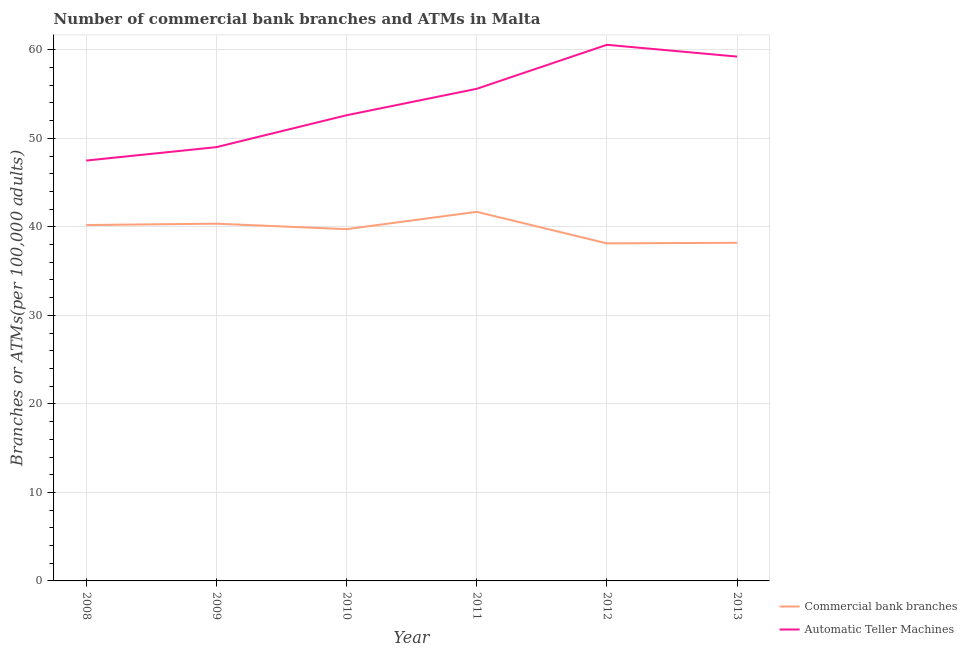Does the line corresponding to number of commercal bank branches intersect with the line corresponding to number of atms?
Your answer should be compact. No. Is the number of lines equal to the number of legend labels?
Offer a terse response. Yes. What is the number of commercal bank branches in 2012?
Your answer should be very brief. 38.14. Across all years, what is the maximum number of atms?
Make the answer very short. 60.57. Across all years, what is the minimum number of atms?
Provide a succinct answer. 47.49. In which year was the number of atms maximum?
Offer a terse response. 2012. What is the total number of atms in the graph?
Provide a short and direct response. 324.51. What is the difference between the number of atms in 2008 and that in 2013?
Give a very brief answer. -11.75. What is the difference between the number of commercal bank branches in 2012 and the number of atms in 2010?
Provide a short and direct response. -14.47. What is the average number of atms per year?
Offer a very short reply. 54.09. In the year 2011, what is the difference between the number of atms and number of commercal bank branches?
Provide a short and direct response. 13.9. In how many years, is the number of commercal bank branches greater than 56?
Your answer should be very brief. 0. What is the ratio of the number of atms in 2008 to that in 2011?
Your answer should be very brief. 0.85. What is the difference between the highest and the second highest number of atms?
Offer a very short reply. 1.33. What is the difference between the highest and the lowest number of atms?
Keep it short and to the point. 13.08. In how many years, is the number of atms greater than the average number of atms taken over all years?
Provide a succinct answer. 3. Does the number of commercal bank branches monotonically increase over the years?
Provide a short and direct response. No. Is the number of commercal bank branches strictly less than the number of atms over the years?
Your response must be concise. Yes. How many lines are there?
Your answer should be very brief. 2. How many years are there in the graph?
Make the answer very short. 6. What is the difference between two consecutive major ticks on the Y-axis?
Ensure brevity in your answer.  10. Are the values on the major ticks of Y-axis written in scientific E-notation?
Provide a short and direct response. No. How are the legend labels stacked?
Make the answer very short. Vertical. What is the title of the graph?
Ensure brevity in your answer.  Number of commercial bank branches and ATMs in Malta. Does "Under-5(female)" appear as one of the legend labels in the graph?
Give a very brief answer. No. What is the label or title of the Y-axis?
Provide a succinct answer. Branches or ATMs(per 100,0 adults). What is the Branches or ATMs(per 100,000 adults) in Commercial bank branches in 2008?
Provide a succinct answer. 40.21. What is the Branches or ATMs(per 100,000 adults) in Automatic Teller Machines in 2008?
Provide a succinct answer. 47.49. What is the Branches or ATMs(per 100,000 adults) of Commercial bank branches in 2009?
Make the answer very short. 40.36. What is the Branches or ATMs(per 100,000 adults) of Automatic Teller Machines in 2009?
Keep it short and to the point. 49.01. What is the Branches or ATMs(per 100,000 adults) in Commercial bank branches in 2010?
Provide a short and direct response. 39.74. What is the Branches or ATMs(per 100,000 adults) in Automatic Teller Machines in 2010?
Provide a short and direct response. 52.61. What is the Branches or ATMs(per 100,000 adults) of Commercial bank branches in 2011?
Offer a very short reply. 41.7. What is the Branches or ATMs(per 100,000 adults) in Automatic Teller Machines in 2011?
Your response must be concise. 55.6. What is the Branches or ATMs(per 100,000 adults) in Commercial bank branches in 2012?
Offer a terse response. 38.14. What is the Branches or ATMs(per 100,000 adults) in Automatic Teller Machines in 2012?
Your answer should be very brief. 60.57. What is the Branches or ATMs(per 100,000 adults) in Commercial bank branches in 2013?
Provide a succinct answer. 38.2. What is the Branches or ATMs(per 100,000 adults) in Automatic Teller Machines in 2013?
Offer a terse response. 59.24. Across all years, what is the maximum Branches or ATMs(per 100,000 adults) in Commercial bank branches?
Your response must be concise. 41.7. Across all years, what is the maximum Branches or ATMs(per 100,000 adults) of Automatic Teller Machines?
Ensure brevity in your answer.  60.57. Across all years, what is the minimum Branches or ATMs(per 100,000 adults) in Commercial bank branches?
Give a very brief answer. 38.14. Across all years, what is the minimum Branches or ATMs(per 100,000 adults) in Automatic Teller Machines?
Offer a very short reply. 47.49. What is the total Branches or ATMs(per 100,000 adults) in Commercial bank branches in the graph?
Ensure brevity in your answer.  238.34. What is the total Branches or ATMs(per 100,000 adults) of Automatic Teller Machines in the graph?
Provide a succinct answer. 324.51. What is the difference between the Branches or ATMs(per 100,000 adults) of Commercial bank branches in 2008 and that in 2009?
Provide a short and direct response. -0.15. What is the difference between the Branches or ATMs(per 100,000 adults) of Automatic Teller Machines in 2008 and that in 2009?
Your answer should be very brief. -1.52. What is the difference between the Branches or ATMs(per 100,000 adults) of Commercial bank branches in 2008 and that in 2010?
Provide a succinct answer. 0.46. What is the difference between the Branches or ATMs(per 100,000 adults) in Automatic Teller Machines in 2008 and that in 2010?
Ensure brevity in your answer.  -5.12. What is the difference between the Branches or ATMs(per 100,000 adults) in Commercial bank branches in 2008 and that in 2011?
Your response must be concise. -1.49. What is the difference between the Branches or ATMs(per 100,000 adults) of Automatic Teller Machines in 2008 and that in 2011?
Make the answer very short. -8.11. What is the difference between the Branches or ATMs(per 100,000 adults) of Commercial bank branches in 2008 and that in 2012?
Offer a very short reply. 2.07. What is the difference between the Branches or ATMs(per 100,000 adults) of Automatic Teller Machines in 2008 and that in 2012?
Offer a terse response. -13.08. What is the difference between the Branches or ATMs(per 100,000 adults) in Commercial bank branches in 2008 and that in 2013?
Your answer should be compact. 2.01. What is the difference between the Branches or ATMs(per 100,000 adults) in Automatic Teller Machines in 2008 and that in 2013?
Offer a terse response. -11.75. What is the difference between the Branches or ATMs(per 100,000 adults) of Commercial bank branches in 2009 and that in 2010?
Your answer should be compact. 0.62. What is the difference between the Branches or ATMs(per 100,000 adults) of Automatic Teller Machines in 2009 and that in 2010?
Ensure brevity in your answer.  -3.6. What is the difference between the Branches or ATMs(per 100,000 adults) of Commercial bank branches in 2009 and that in 2011?
Offer a terse response. -1.34. What is the difference between the Branches or ATMs(per 100,000 adults) in Automatic Teller Machines in 2009 and that in 2011?
Offer a very short reply. -6.59. What is the difference between the Branches or ATMs(per 100,000 adults) of Commercial bank branches in 2009 and that in 2012?
Give a very brief answer. 2.22. What is the difference between the Branches or ATMs(per 100,000 adults) of Automatic Teller Machines in 2009 and that in 2012?
Your answer should be compact. -11.56. What is the difference between the Branches or ATMs(per 100,000 adults) in Commercial bank branches in 2009 and that in 2013?
Your answer should be very brief. 2.16. What is the difference between the Branches or ATMs(per 100,000 adults) of Automatic Teller Machines in 2009 and that in 2013?
Offer a terse response. -10.23. What is the difference between the Branches or ATMs(per 100,000 adults) in Commercial bank branches in 2010 and that in 2011?
Keep it short and to the point. -1.96. What is the difference between the Branches or ATMs(per 100,000 adults) of Automatic Teller Machines in 2010 and that in 2011?
Ensure brevity in your answer.  -2.99. What is the difference between the Branches or ATMs(per 100,000 adults) in Commercial bank branches in 2010 and that in 2012?
Offer a terse response. 1.61. What is the difference between the Branches or ATMs(per 100,000 adults) in Automatic Teller Machines in 2010 and that in 2012?
Provide a short and direct response. -7.96. What is the difference between the Branches or ATMs(per 100,000 adults) of Commercial bank branches in 2010 and that in 2013?
Give a very brief answer. 1.54. What is the difference between the Branches or ATMs(per 100,000 adults) of Automatic Teller Machines in 2010 and that in 2013?
Ensure brevity in your answer.  -6.63. What is the difference between the Branches or ATMs(per 100,000 adults) of Commercial bank branches in 2011 and that in 2012?
Your answer should be compact. 3.56. What is the difference between the Branches or ATMs(per 100,000 adults) in Automatic Teller Machines in 2011 and that in 2012?
Keep it short and to the point. -4.97. What is the difference between the Branches or ATMs(per 100,000 adults) in Commercial bank branches in 2011 and that in 2013?
Ensure brevity in your answer.  3.5. What is the difference between the Branches or ATMs(per 100,000 adults) in Automatic Teller Machines in 2011 and that in 2013?
Provide a succinct answer. -3.64. What is the difference between the Branches or ATMs(per 100,000 adults) in Commercial bank branches in 2012 and that in 2013?
Keep it short and to the point. -0.06. What is the difference between the Branches or ATMs(per 100,000 adults) of Automatic Teller Machines in 2012 and that in 2013?
Provide a succinct answer. 1.33. What is the difference between the Branches or ATMs(per 100,000 adults) of Commercial bank branches in 2008 and the Branches or ATMs(per 100,000 adults) of Automatic Teller Machines in 2009?
Provide a short and direct response. -8.8. What is the difference between the Branches or ATMs(per 100,000 adults) in Commercial bank branches in 2008 and the Branches or ATMs(per 100,000 adults) in Automatic Teller Machines in 2010?
Offer a terse response. -12.4. What is the difference between the Branches or ATMs(per 100,000 adults) in Commercial bank branches in 2008 and the Branches or ATMs(per 100,000 adults) in Automatic Teller Machines in 2011?
Your response must be concise. -15.39. What is the difference between the Branches or ATMs(per 100,000 adults) of Commercial bank branches in 2008 and the Branches or ATMs(per 100,000 adults) of Automatic Teller Machines in 2012?
Offer a very short reply. -20.36. What is the difference between the Branches or ATMs(per 100,000 adults) in Commercial bank branches in 2008 and the Branches or ATMs(per 100,000 adults) in Automatic Teller Machines in 2013?
Your response must be concise. -19.03. What is the difference between the Branches or ATMs(per 100,000 adults) of Commercial bank branches in 2009 and the Branches or ATMs(per 100,000 adults) of Automatic Teller Machines in 2010?
Your answer should be very brief. -12.25. What is the difference between the Branches or ATMs(per 100,000 adults) in Commercial bank branches in 2009 and the Branches or ATMs(per 100,000 adults) in Automatic Teller Machines in 2011?
Your response must be concise. -15.24. What is the difference between the Branches or ATMs(per 100,000 adults) of Commercial bank branches in 2009 and the Branches or ATMs(per 100,000 adults) of Automatic Teller Machines in 2012?
Offer a terse response. -20.21. What is the difference between the Branches or ATMs(per 100,000 adults) of Commercial bank branches in 2009 and the Branches or ATMs(per 100,000 adults) of Automatic Teller Machines in 2013?
Offer a terse response. -18.88. What is the difference between the Branches or ATMs(per 100,000 adults) of Commercial bank branches in 2010 and the Branches or ATMs(per 100,000 adults) of Automatic Teller Machines in 2011?
Offer a terse response. -15.85. What is the difference between the Branches or ATMs(per 100,000 adults) of Commercial bank branches in 2010 and the Branches or ATMs(per 100,000 adults) of Automatic Teller Machines in 2012?
Offer a terse response. -20.83. What is the difference between the Branches or ATMs(per 100,000 adults) of Commercial bank branches in 2010 and the Branches or ATMs(per 100,000 adults) of Automatic Teller Machines in 2013?
Offer a very short reply. -19.49. What is the difference between the Branches or ATMs(per 100,000 adults) in Commercial bank branches in 2011 and the Branches or ATMs(per 100,000 adults) in Automatic Teller Machines in 2012?
Make the answer very short. -18.87. What is the difference between the Branches or ATMs(per 100,000 adults) of Commercial bank branches in 2011 and the Branches or ATMs(per 100,000 adults) of Automatic Teller Machines in 2013?
Keep it short and to the point. -17.54. What is the difference between the Branches or ATMs(per 100,000 adults) in Commercial bank branches in 2012 and the Branches or ATMs(per 100,000 adults) in Automatic Teller Machines in 2013?
Make the answer very short. -21.1. What is the average Branches or ATMs(per 100,000 adults) of Commercial bank branches per year?
Give a very brief answer. 39.72. What is the average Branches or ATMs(per 100,000 adults) of Automatic Teller Machines per year?
Provide a succinct answer. 54.09. In the year 2008, what is the difference between the Branches or ATMs(per 100,000 adults) of Commercial bank branches and Branches or ATMs(per 100,000 adults) of Automatic Teller Machines?
Offer a terse response. -7.28. In the year 2009, what is the difference between the Branches or ATMs(per 100,000 adults) of Commercial bank branches and Branches or ATMs(per 100,000 adults) of Automatic Teller Machines?
Your answer should be compact. -8.65. In the year 2010, what is the difference between the Branches or ATMs(per 100,000 adults) in Commercial bank branches and Branches or ATMs(per 100,000 adults) in Automatic Teller Machines?
Keep it short and to the point. -12.87. In the year 2011, what is the difference between the Branches or ATMs(per 100,000 adults) in Commercial bank branches and Branches or ATMs(per 100,000 adults) in Automatic Teller Machines?
Make the answer very short. -13.9. In the year 2012, what is the difference between the Branches or ATMs(per 100,000 adults) of Commercial bank branches and Branches or ATMs(per 100,000 adults) of Automatic Teller Machines?
Make the answer very short. -22.43. In the year 2013, what is the difference between the Branches or ATMs(per 100,000 adults) of Commercial bank branches and Branches or ATMs(per 100,000 adults) of Automatic Teller Machines?
Provide a short and direct response. -21.04. What is the ratio of the Branches or ATMs(per 100,000 adults) of Commercial bank branches in 2008 to that in 2009?
Offer a very short reply. 1. What is the ratio of the Branches or ATMs(per 100,000 adults) of Commercial bank branches in 2008 to that in 2010?
Make the answer very short. 1.01. What is the ratio of the Branches or ATMs(per 100,000 adults) in Automatic Teller Machines in 2008 to that in 2010?
Your answer should be very brief. 0.9. What is the ratio of the Branches or ATMs(per 100,000 adults) of Commercial bank branches in 2008 to that in 2011?
Provide a succinct answer. 0.96. What is the ratio of the Branches or ATMs(per 100,000 adults) in Automatic Teller Machines in 2008 to that in 2011?
Your response must be concise. 0.85. What is the ratio of the Branches or ATMs(per 100,000 adults) in Commercial bank branches in 2008 to that in 2012?
Your response must be concise. 1.05. What is the ratio of the Branches or ATMs(per 100,000 adults) in Automatic Teller Machines in 2008 to that in 2012?
Ensure brevity in your answer.  0.78. What is the ratio of the Branches or ATMs(per 100,000 adults) of Commercial bank branches in 2008 to that in 2013?
Make the answer very short. 1.05. What is the ratio of the Branches or ATMs(per 100,000 adults) in Automatic Teller Machines in 2008 to that in 2013?
Your response must be concise. 0.8. What is the ratio of the Branches or ATMs(per 100,000 adults) in Commercial bank branches in 2009 to that in 2010?
Give a very brief answer. 1.02. What is the ratio of the Branches or ATMs(per 100,000 adults) in Automatic Teller Machines in 2009 to that in 2010?
Offer a terse response. 0.93. What is the ratio of the Branches or ATMs(per 100,000 adults) of Commercial bank branches in 2009 to that in 2011?
Ensure brevity in your answer.  0.97. What is the ratio of the Branches or ATMs(per 100,000 adults) in Automatic Teller Machines in 2009 to that in 2011?
Offer a very short reply. 0.88. What is the ratio of the Branches or ATMs(per 100,000 adults) in Commercial bank branches in 2009 to that in 2012?
Your answer should be compact. 1.06. What is the ratio of the Branches or ATMs(per 100,000 adults) of Automatic Teller Machines in 2009 to that in 2012?
Give a very brief answer. 0.81. What is the ratio of the Branches or ATMs(per 100,000 adults) in Commercial bank branches in 2009 to that in 2013?
Keep it short and to the point. 1.06. What is the ratio of the Branches or ATMs(per 100,000 adults) in Automatic Teller Machines in 2009 to that in 2013?
Make the answer very short. 0.83. What is the ratio of the Branches or ATMs(per 100,000 adults) of Commercial bank branches in 2010 to that in 2011?
Your response must be concise. 0.95. What is the ratio of the Branches or ATMs(per 100,000 adults) of Automatic Teller Machines in 2010 to that in 2011?
Your answer should be very brief. 0.95. What is the ratio of the Branches or ATMs(per 100,000 adults) of Commercial bank branches in 2010 to that in 2012?
Provide a succinct answer. 1.04. What is the ratio of the Branches or ATMs(per 100,000 adults) of Automatic Teller Machines in 2010 to that in 2012?
Give a very brief answer. 0.87. What is the ratio of the Branches or ATMs(per 100,000 adults) of Commercial bank branches in 2010 to that in 2013?
Your response must be concise. 1.04. What is the ratio of the Branches or ATMs(per 100,000 adults) of Automatic Teller Machines in 2010 to that in 2013?
Your response must be concise. 0.89. What is the ratio of the Branches or ATMs(per 100,000 adults) in Commercial bank branches in 2011 to that in 2012?
Offer a terse response. 1.09. What is the ratio of the Branches or ATMs(per 100,000 adults) in Automatic Teller Machines in 2011 to that in 2012?
Provide a succinct answer. 0.92. What is the ratio of the Branches or ATMs(per 100,000 adults) in Commercial bank branches in 2011 to that in 2013?
Your answer should be compact. 1.09. What is the ratio of the Branches or ATMs(per 100,000 adults) in Automatic Teller Machines in 2011 to that in 2013?
Keep it short and to the point. 0.94. What is the ratio of the Branches or ATMs(per 100,000 adults) of Commercial bank branches in 2012 to that in 2013?
Make the answer very short. 1. What is the ratio of the Branches or ATMs(per 100,000 adults) in Automatic Teller Machines in 2012 to that in 2013?
Provide a short and direct response. 1.02. What is the difference between the highest and the second highest Branches or ATMs(per 100,000 adults) of Commercial bank branches?
Offer a terse response. 1.34. What is the difference between the highest and the second highest Branches or ATMs(per 100,000 adults) in Automatic Teller Machines?
Provide a short and direct response. 1.33. What is the difference between the highest and the lowest Branches or ATMs(per 100,000 adults) in Commercial bank branches?
Provide a succinct answer. 3.56. What is the difference between the highest and the lowest Branches or ATMs(per 100,000 adults) of Automatic Teller Machines?
Offer a terse response. 13.08. 